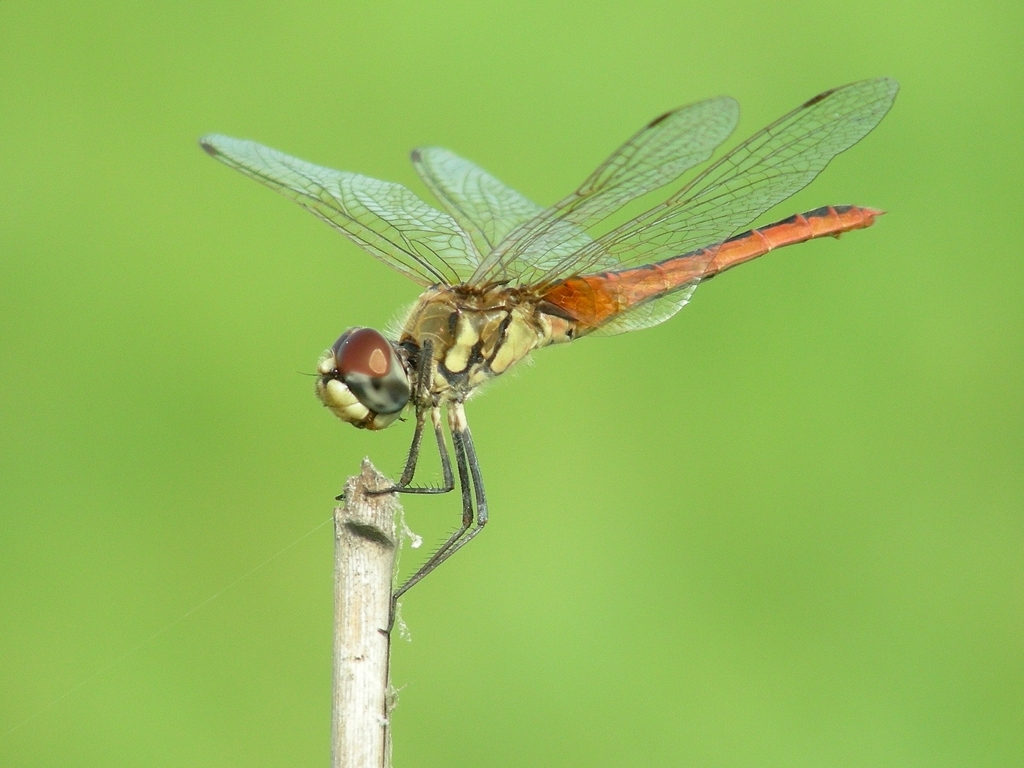How do dragonflies contribute to their ecosystem? Dragonflies are apex aerial predators in their larval and adult stages, which helps control populations of mosquitoes and other small insects. Their presence indicates a balanced ecosystem, and their life cycles provide insights into the health of aquatic and terrestrial systems. 